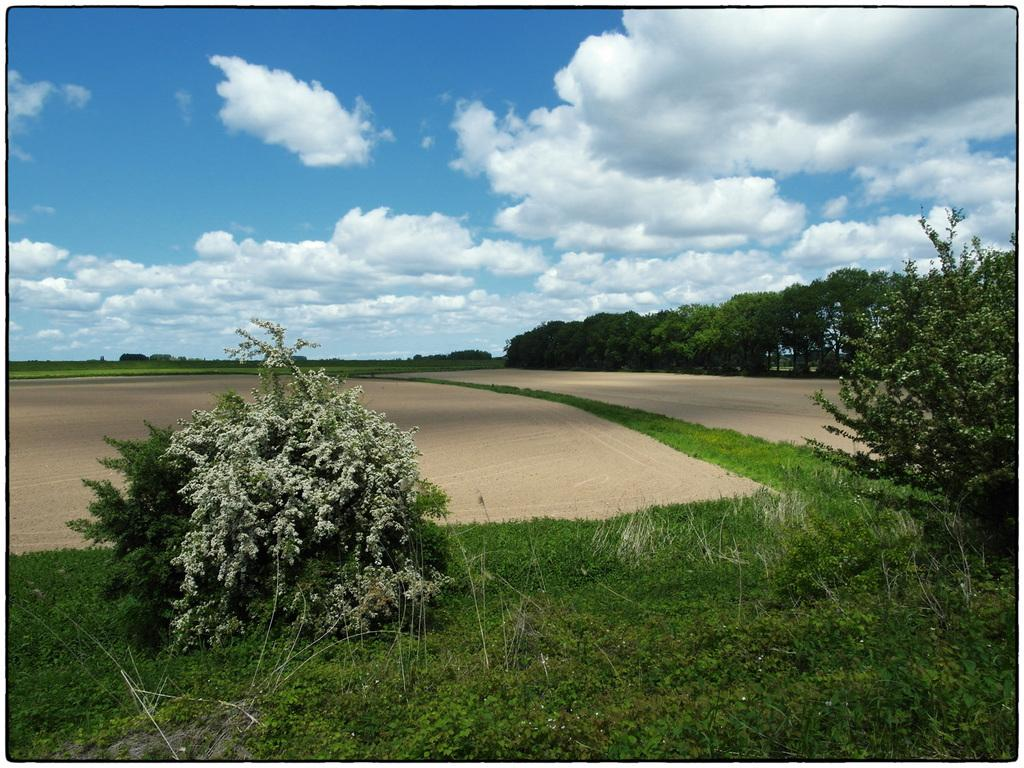What type of vegetation is in the foreground of the image? There are plants and grassland in the foreground of the image. What can be seen in the background of the image? There are trees, a road, and the sky visible in the background of the image. What type of ink is being used to write on the trees in the background? There is no ink or writing present on the trees in the image. How many planes can be seen flying over the grassland in the foreground? There are no planes visible in the image. 